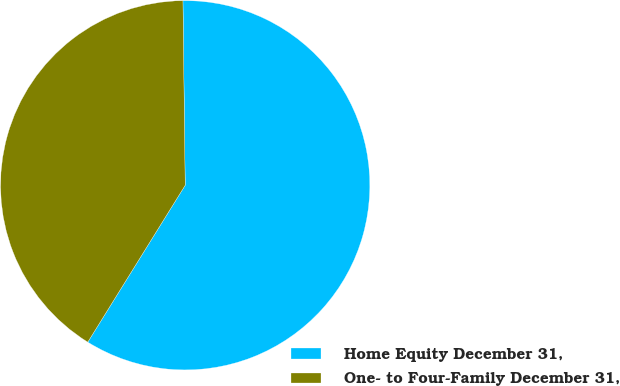Convert chart to OTSL. <chart><loc_0><loc_0><loc_500><loc_500><pie_chart><fcel>Home Equity December 31,<fcel>One- to Four-Family December 31,<nl><fcel>59.04%<fcel>40.96%<nl></chart> 